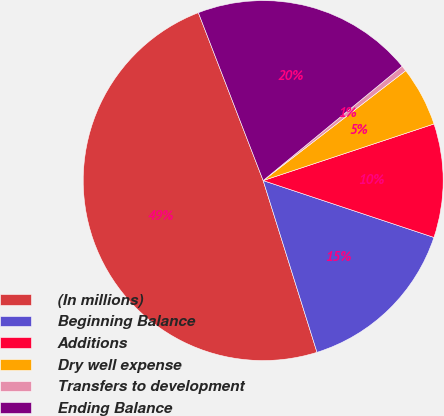Convert chart. <chart><loc_0><loc_0><loc_500><loc_500><pie_chart><fcel>(In millions)<fcel>Beginning Balance<fcel>Additions<fcel>Dry well expense<fcel>Transfers to development<fcel>Ending Balance<nl><fcel>48.97%<fcel>15.05%<fcel>10.21%<fcel>5.36%<fcel>0.51%<fcel>19.9%<nl></chart> 